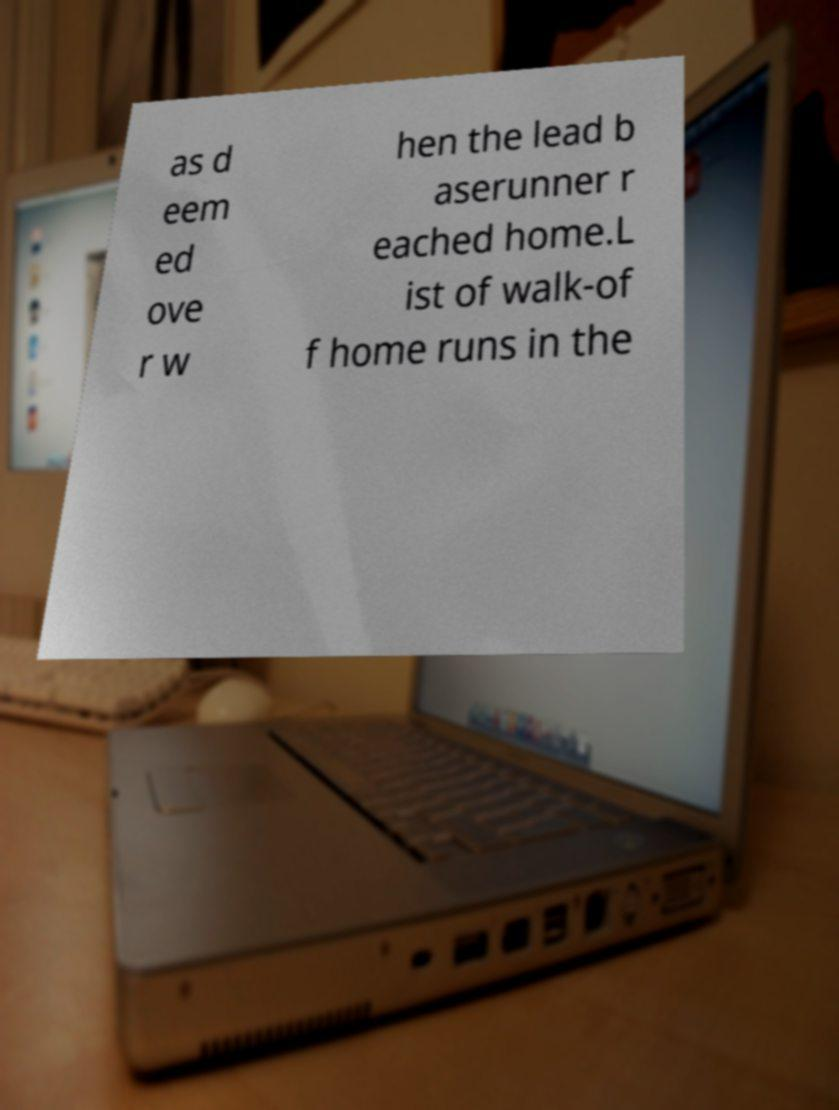Could you extract and type out the text from this image? as d eem ed ove r w hen the lead b aserunner r eached home.L ist of walk-of f home runs in the 